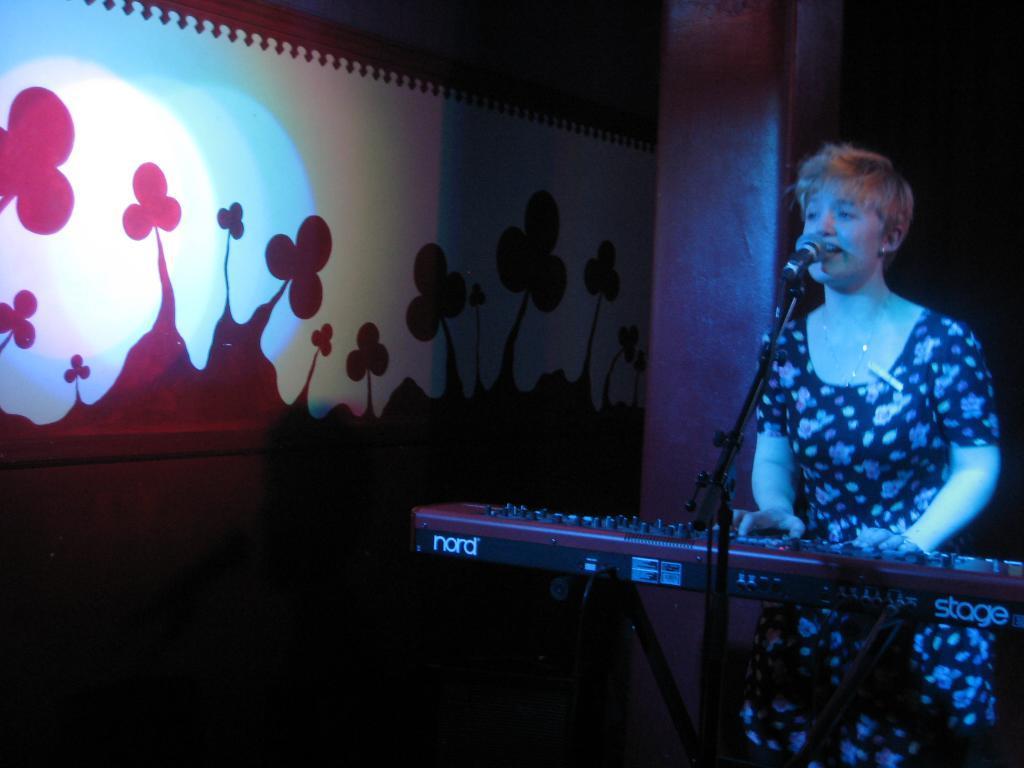In one or two sentences, can you explain what this image depicts? In this picture I can see there is a woman standing and playing the piano and there is a microphone stand in front of her and on to left there is a wall with a painting. 